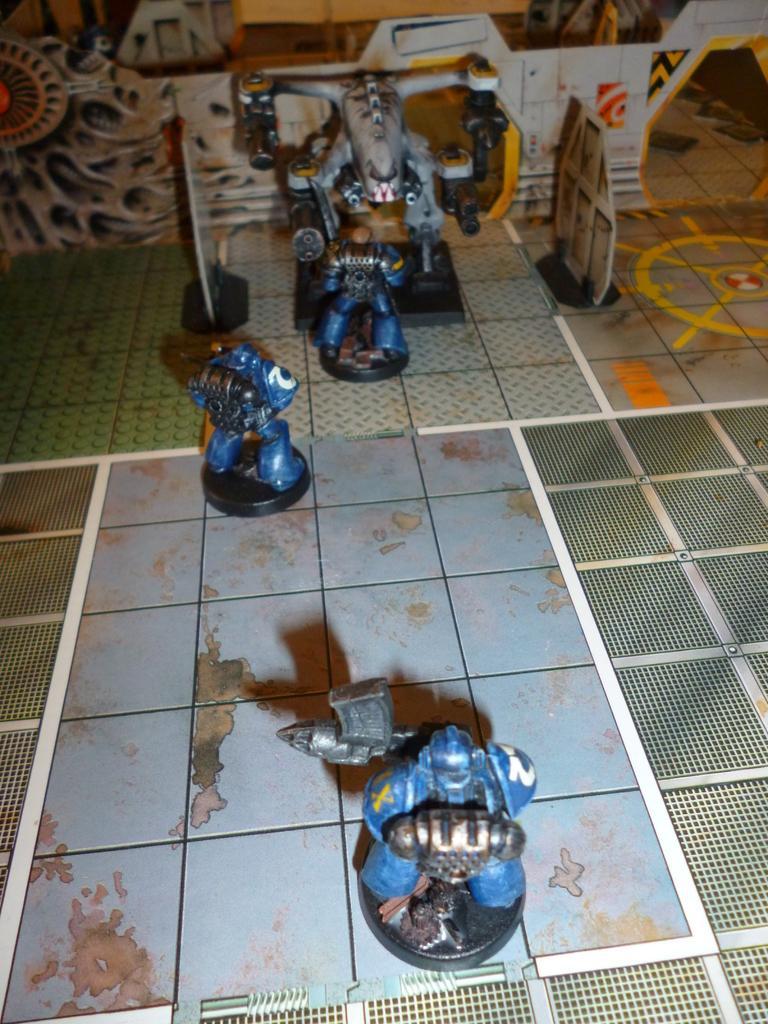Describe this image in one or two sentences. In this picture there are few toys on the ground and there are few other objects in the background. 